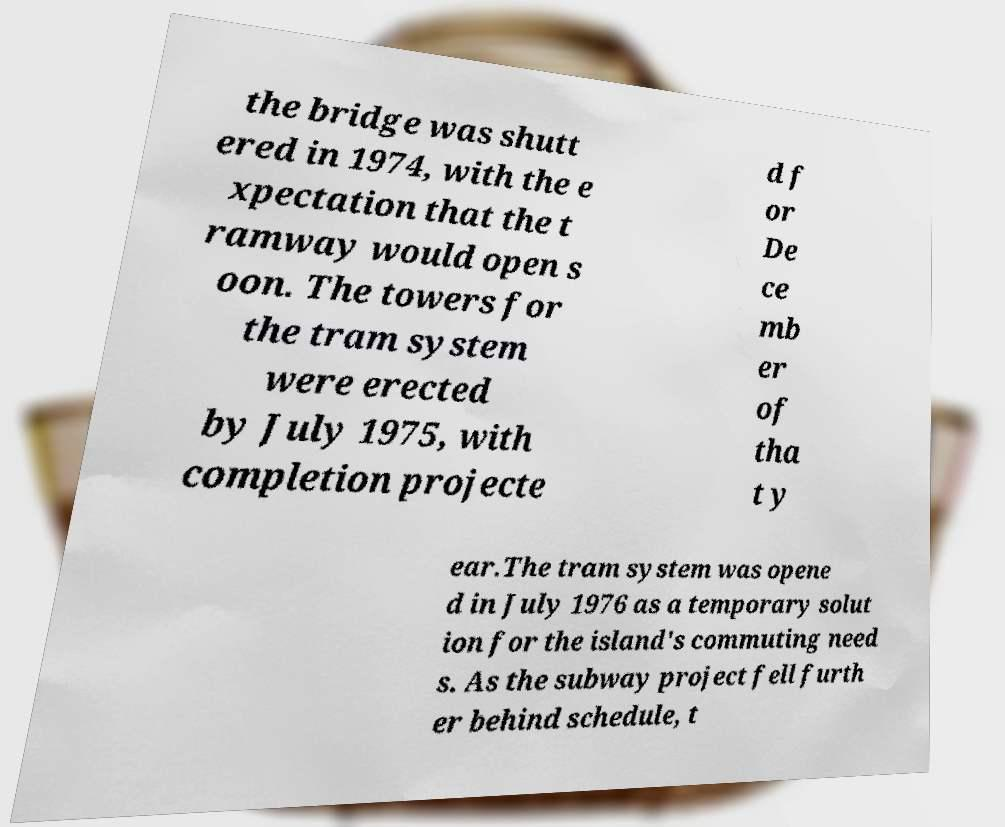I need the written content from this picture converted into text. Can you do that? the bridge was shutt ered in 1974, with the e xpectation that the t ramway would open s oon. The towers for the tram system were erected by July 1975, with completion projecte d f or De ce mb er of tha t y ear.The tram system was opene d in July 1976 as a temporary solut ion for the island's commuting need s. As the subway project fell furth er behind schedule, t 